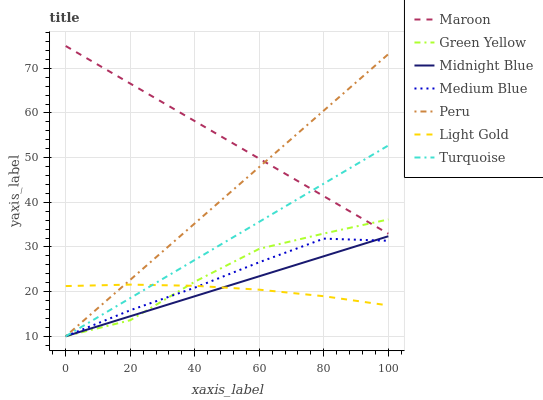Does Light Gold have the minimum area under the curve?
Answer yes or no. Yes. Does Maroon have the maximum area under the curve?
Answer yes or no. Yes. Does Midnight Blue have the minimum area under the curve?
Answer yes or no. No. Does Midnight Blue have the maximum area under the curve?
Answer yes or no. No. Is Midnight Blue the smoothest?
Answer yes or no. Yes. Is Green Yellow the roughest?
Answer yes or no. Yes. Is Medium Blue the smoothest?
Answer yes or no. No. Is Medium Blue the roughest?
Answer yes or no. No. Does Turquoise have the lowest value?
Answer yes or no. Yes. Does Maroon have the lowest value?
Answer yes or no. No. Does Maroon have the highest value?
Answer yes or no. Yes. Does Midnight Blue have the highest value?
Answer yes or no. No. Is Medium Blue less than Maroon?
Answer yes or no. Yes. Is Maroon greater than Midnight Blue?
Answer yes or no. Yes. Does Light Gold intersect Midnight Blue?
Answer yes or no. Yes. Is Light Gold less than Midnight Blue?
Answer yes or no. No. Is Light Gold greater than Midnight Blue?
Answer yes or no. No. Does Medium Blue intersect Maroon?
Answer yes or no. No. 